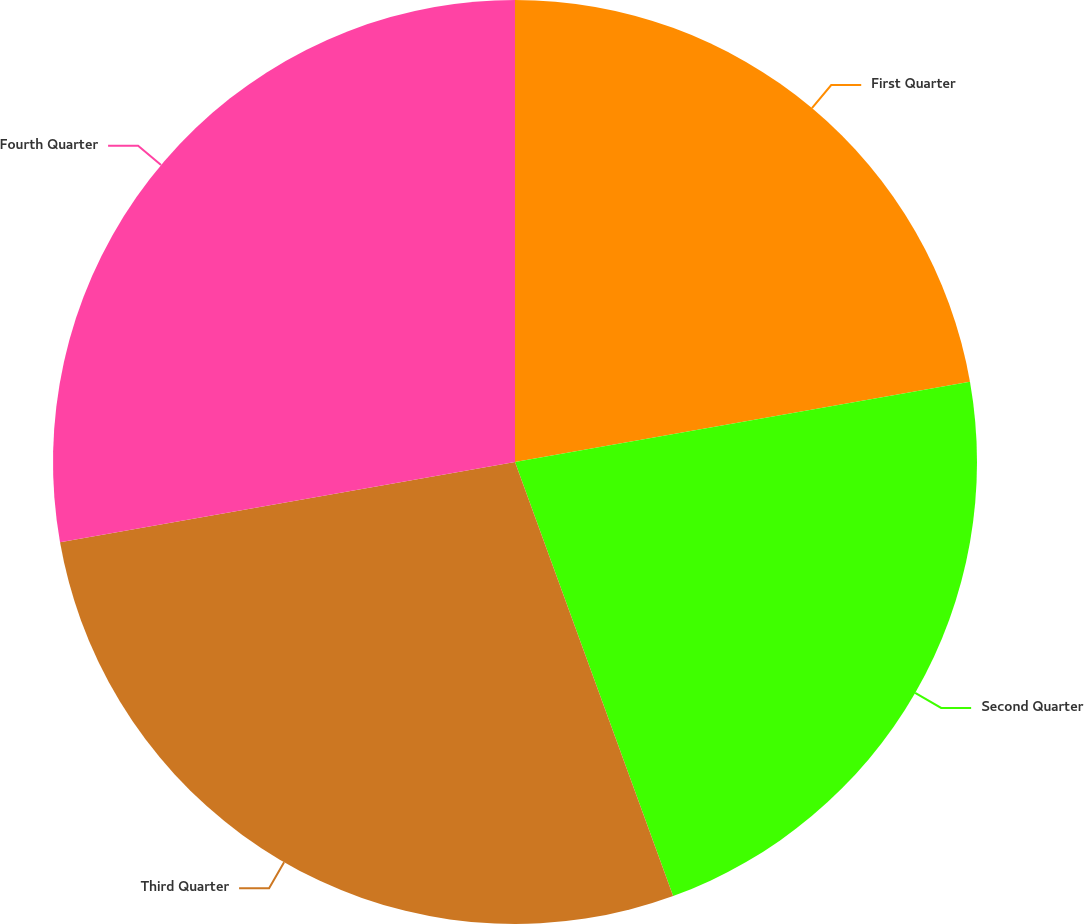<chart> <loc_0><loc_0><loc_500><loc_500><pie_chart><fcel>First Quarter<fcel>Second Quarter<fcel>Third Quarter<fcel>Fourth Quarter<nl><fcel>22.22%<fcel>22.22%<fcel>27.78%<fcel>27.78%<nl></chart> 